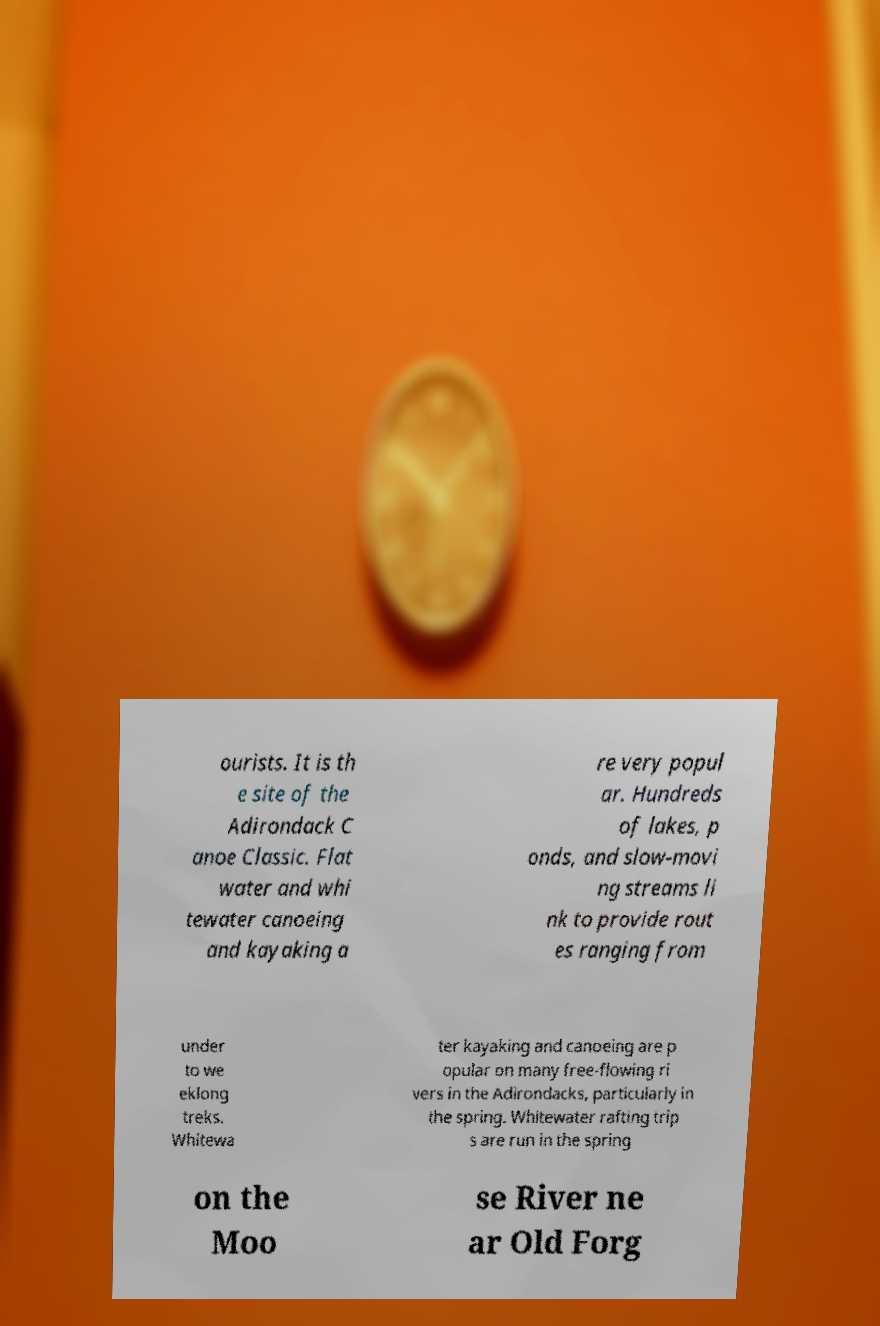What messages or text are displayed in this image? I need them in a readable, typed format. ourists. It is th e site of the Adirondack C anoe Classic. Flat water and whi tewater canoeing and kayaking a re very popul ar. Hundreds of lakes, p onds, and slow-movi ng streams li nk to provide rout es ranging from under to we eklong treks. Whitewa ter kayaking and canoeing are p opular on many free-flowing ri vers in the Adirondacks, particularly in the spring. Whitewater rafting trip s are run in the spring on the Moo se River ne ar Old Forg 